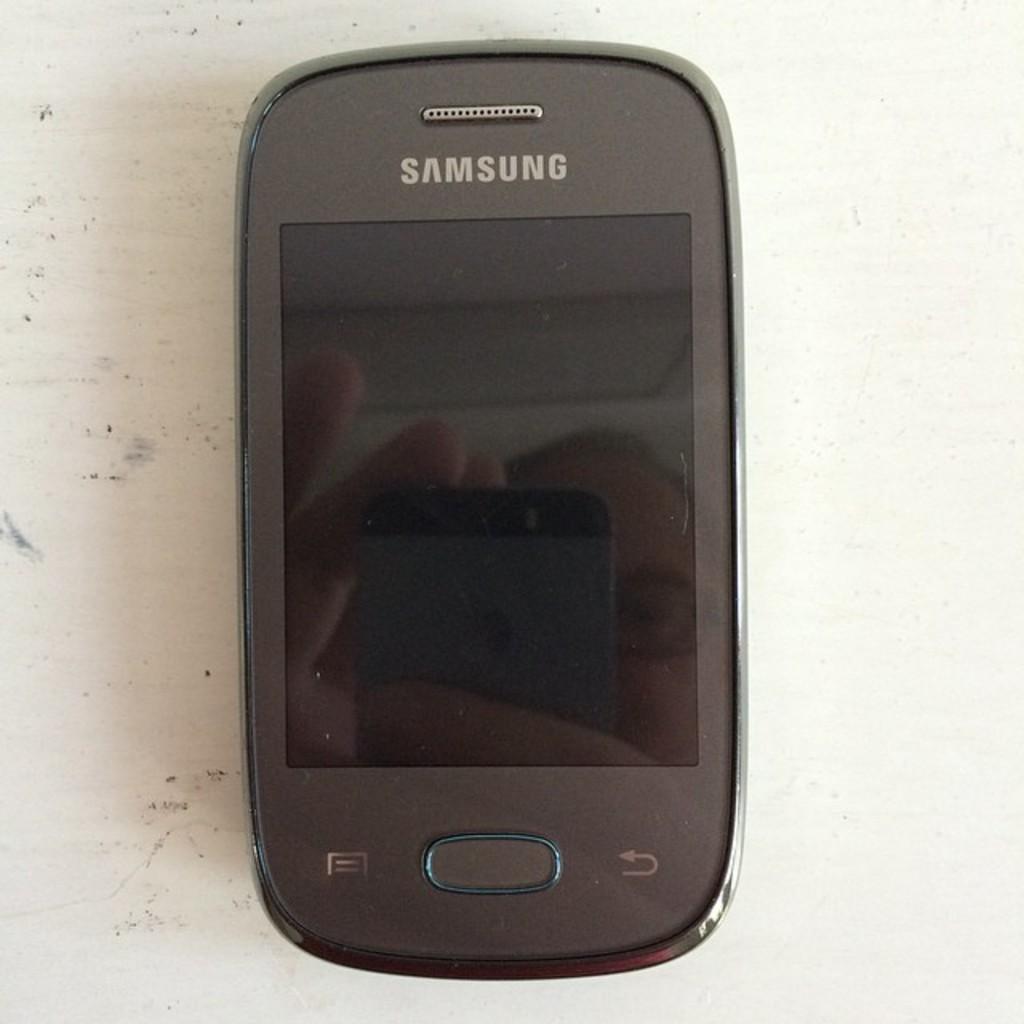Which phone company built the phone?
Offer a very short reply. Samsung. What is the brand of phone?
Provide a succinct answer. Samsung. 